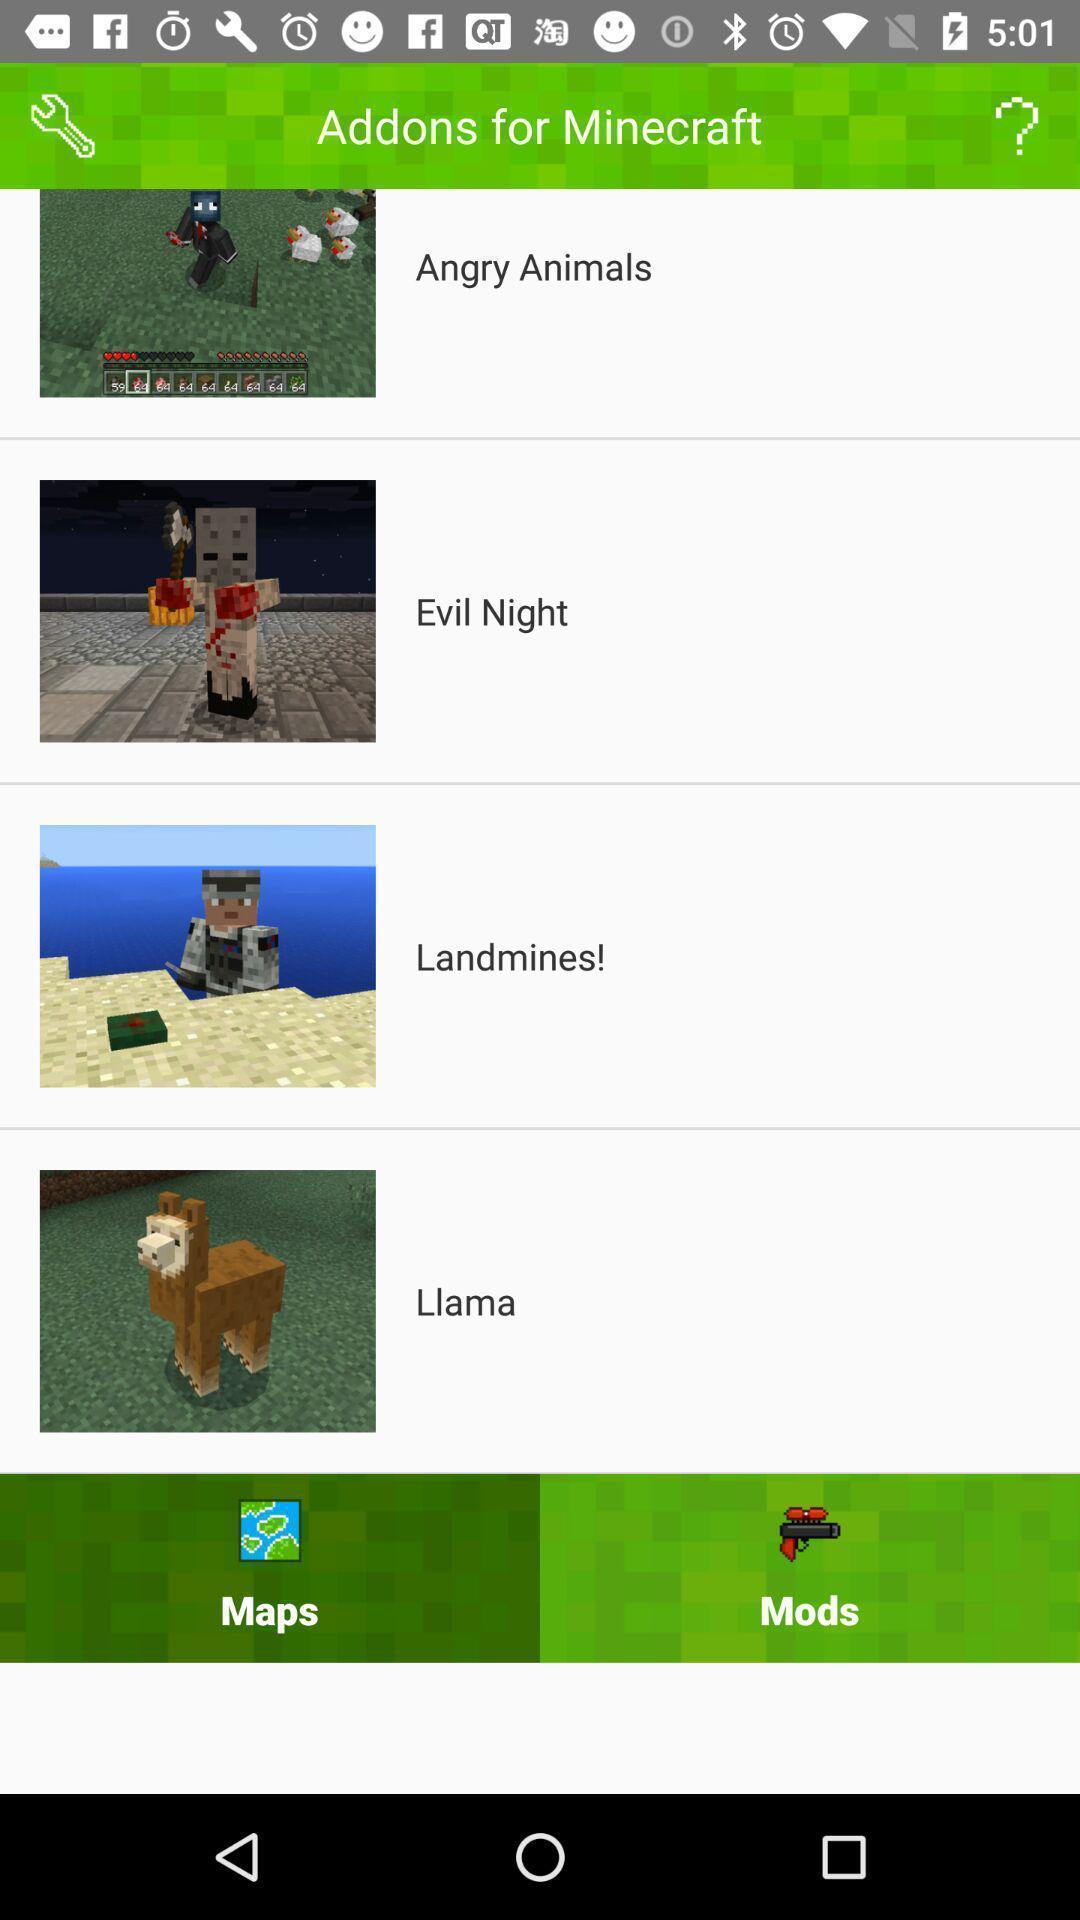Give me a summary of this screen capture. Screen shows add ons for minecraft. 